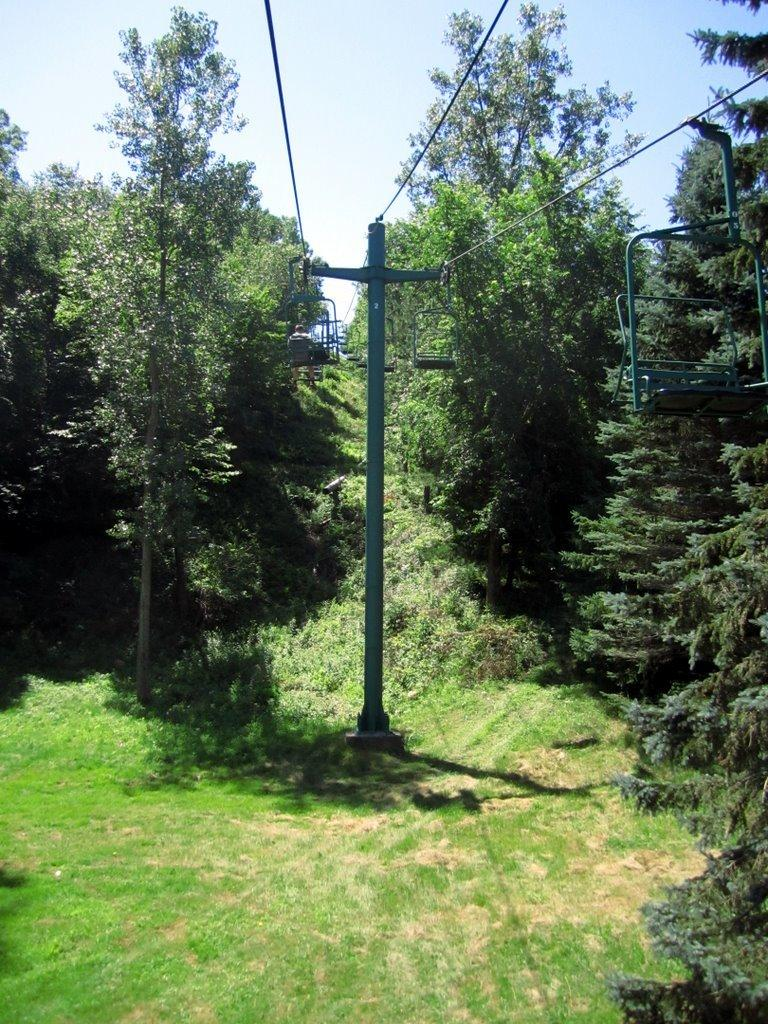What is the main structure in the center of the image? There is a pole in the center of the image. What is attached to the top of the pole? There are cable cars on top of the pole. What connects the pole and cable cars? There are wires associated with the pole and cable cars. What can be seen in the background of the image? There are trees in the background of the image. What type of ground is visible at the bottom of the image? There is grass visible at the bottom of the image. How many servants are visible in the image? There are no servants present in the image. What type of finger can be seen holding the cable car in the image? There are no fingers or hands visible in the image; the cable cars are attached to the pole and wires. 